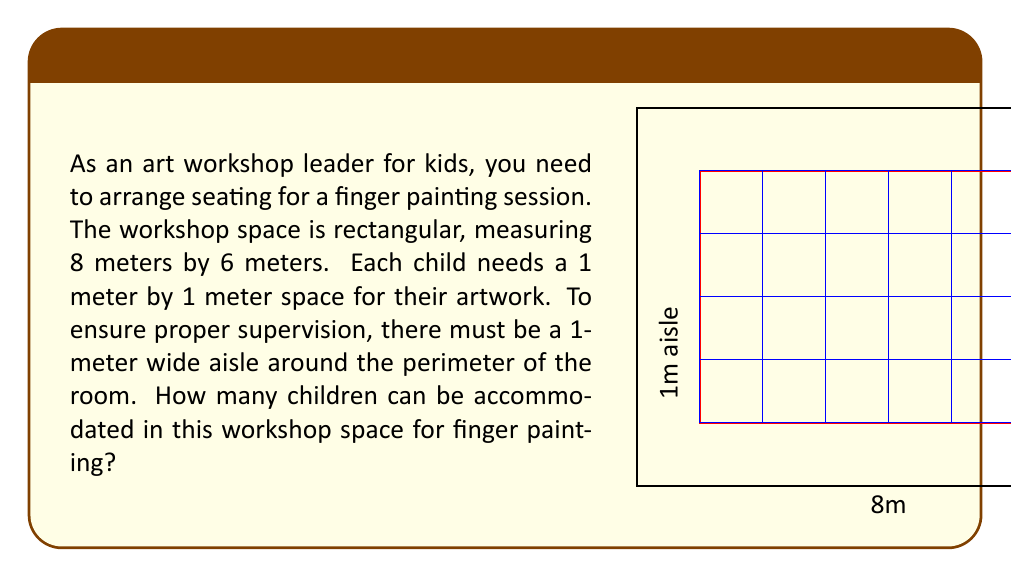What is the answer to this math problem? Let's approach this step-by-step:

1) First, we need to calculate the available space for seating after accounting for the aisle:
   - Width: $8m - 2m$ (for aisles) $= 6m$
   - Length: $6m - 2m$ (for aisles) $= 4m$

2) Now we have a $6m \times 4m$ area for seating.

3) Each child needs a $1m \times 1m$ space.

4) To find the number of children that can be seated:
   - In the width: $6m \div 1m = 6$ children
   - In the length: $4m \div 1m = 4$ children

5) Total number of children:
   $$ \text{Number of children} = 6 \times 4 = 24 $$

Therefore, 24 children can be accommodated in this workshop space for finger painting.
Answer: 24 children 